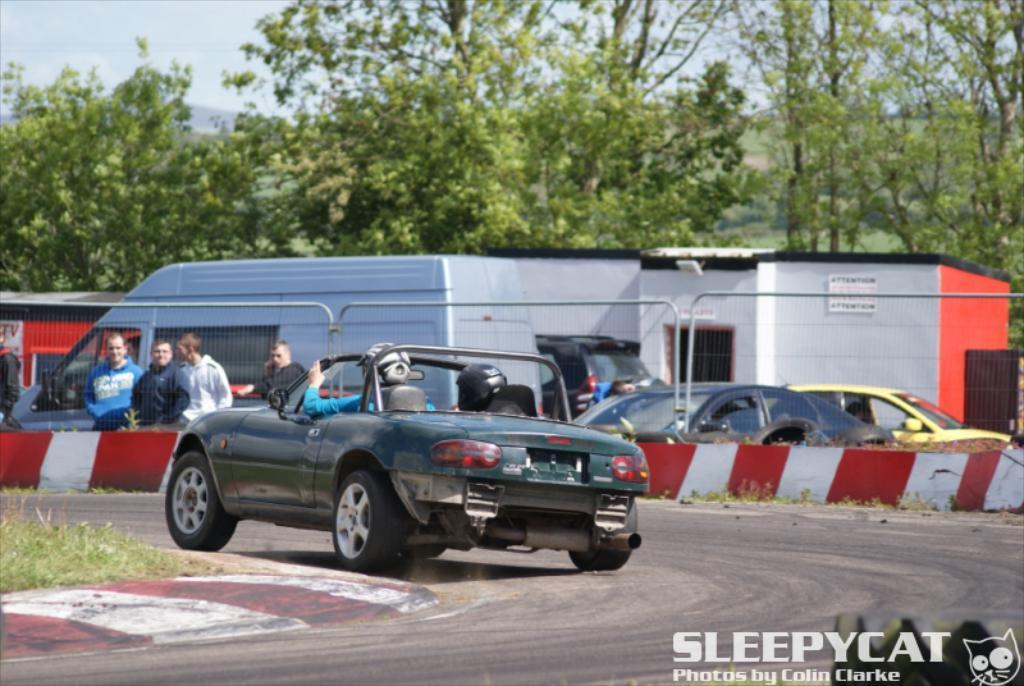How would you summarize this image in a sentence or two? In the middle there is a car inside the car there is a man. On the left there are few people and vehicles. At the bottom there is a road and grass. In the background there are trees ,hill and sky. 